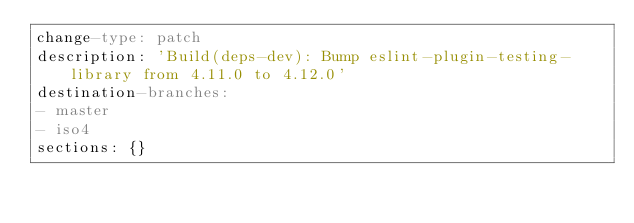Convert code to text. <code><loc_0><loc_0><loc_500><loc_500><_YAML_>change-type: patch
description: 'Build(deps-dev): Bump eslint-plugin-testing-library from 4.11.0 to 4.12.0'
destination-branches:
- master
- iso4
sections: {}
</code> 